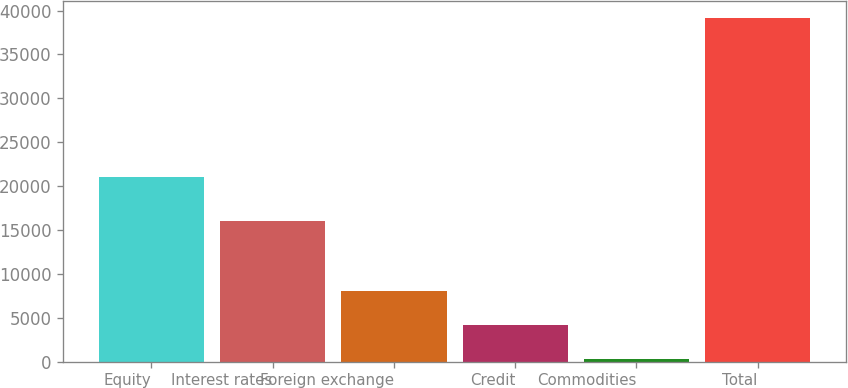Convert chart to OTSL. <chart><loc_0><loc_0><loc_500><loc_500><bar_chart><fcel>Equity<fcel>Interest rates<fcel>Foreign exchange<fcel>Credit<fcel>Commodities<fcel>Total<nl><fcel>21066<fcel>16051<fcel>8039.6<fcel>4151.8<fcel>264<fcel>39142<nl></chart> 